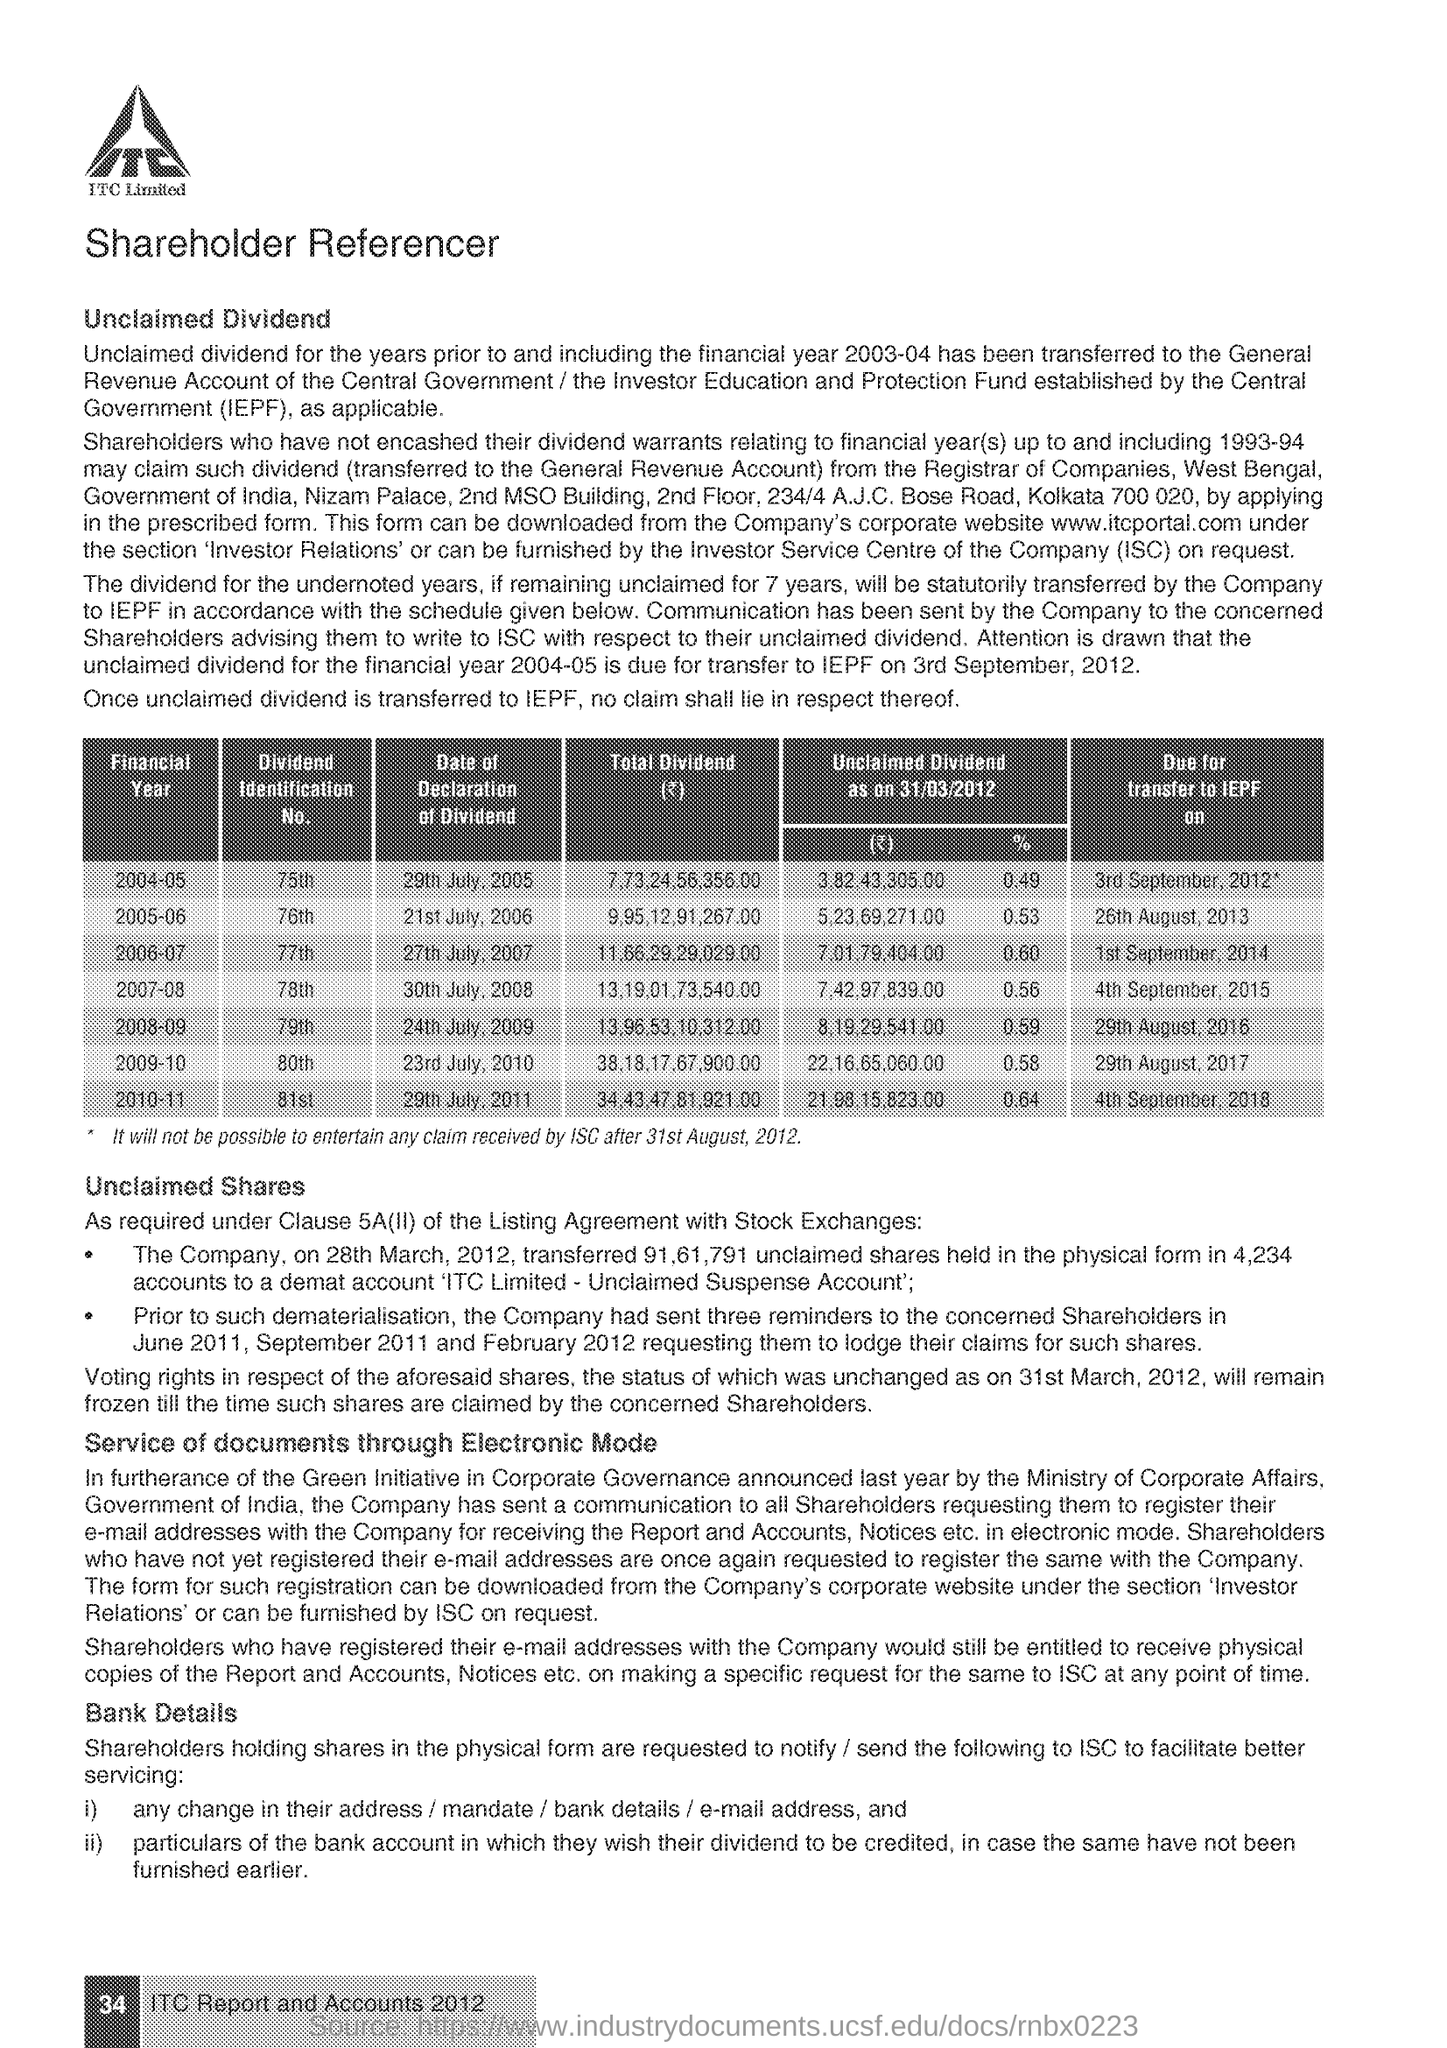What is the Company Name ?
Your answer should be compact. ITC Limited. What is the Fullform of IEPF ?
Your answer should be very brief. Investor Education and Protection Fund. What is the Fullform of ISC ?
Offer a terse response. Investor Service Centre. 